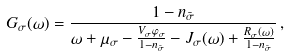Convert formula to latex. <formula><loc_0><loc_0><loc_500><loc_500>G _ { \sigma } ( \omega ) = \frac { 1 - n _ { \bar { \sigma } } } { \omega + \mu _ { \sigma } - \frac { V _ { \sigma } \varphi _ { \sigma } } { 1 - n _ { \bar { \sigma } } } - J _ { \sigma } ( \omega ) + \frac { R _ { \sigma } ( \omega ) } { 1 - n _ { \bar { \sigma } } } } \, ,</formula> 